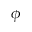<formula> <loc_0><loc_0><loc_500><loc_500>\phi</formula> 